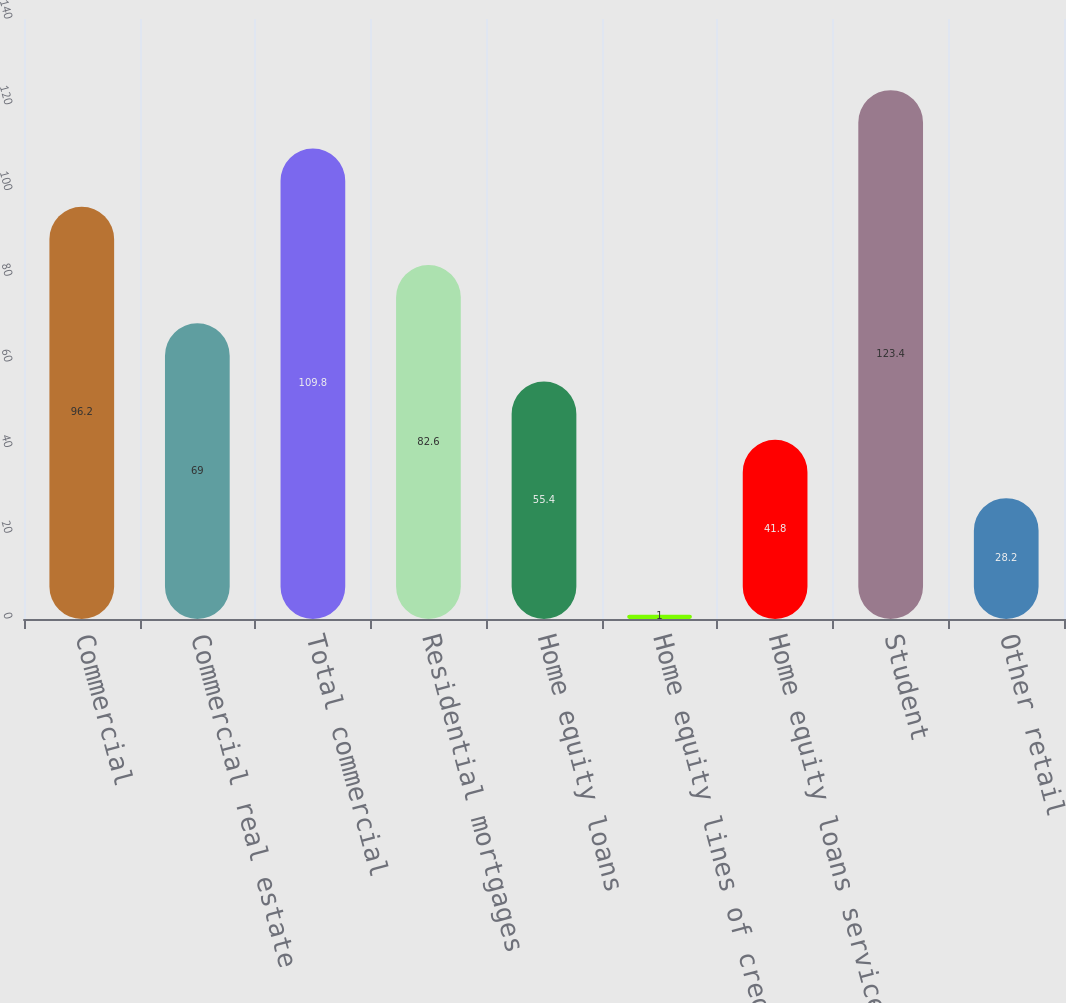Convert chart to OTSL. <chart><loc_0><loc_0><loc_500><loc_500><bar_chart><fcel>Commercial<fcel>Commercial real estate<fcel>Total commercial<fcel>Residential mortgages<fcel>Home equity loans<fcel>Home equity lines of credit<fcel>Home equity loans serviced by<fcel>Student<fcel>Other retail<nl><fcel>96.2<fcel>69<fcel>109.8<fcel>82.6<fcel>55.4<fcel>1<fcel>41.8<fcel>123.4<fcel>28.2<nl></chart> 